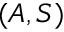Convert formula to latex. <formula><loc_0><loc_0><loc_500><loc_500>( A , S )</formula> 